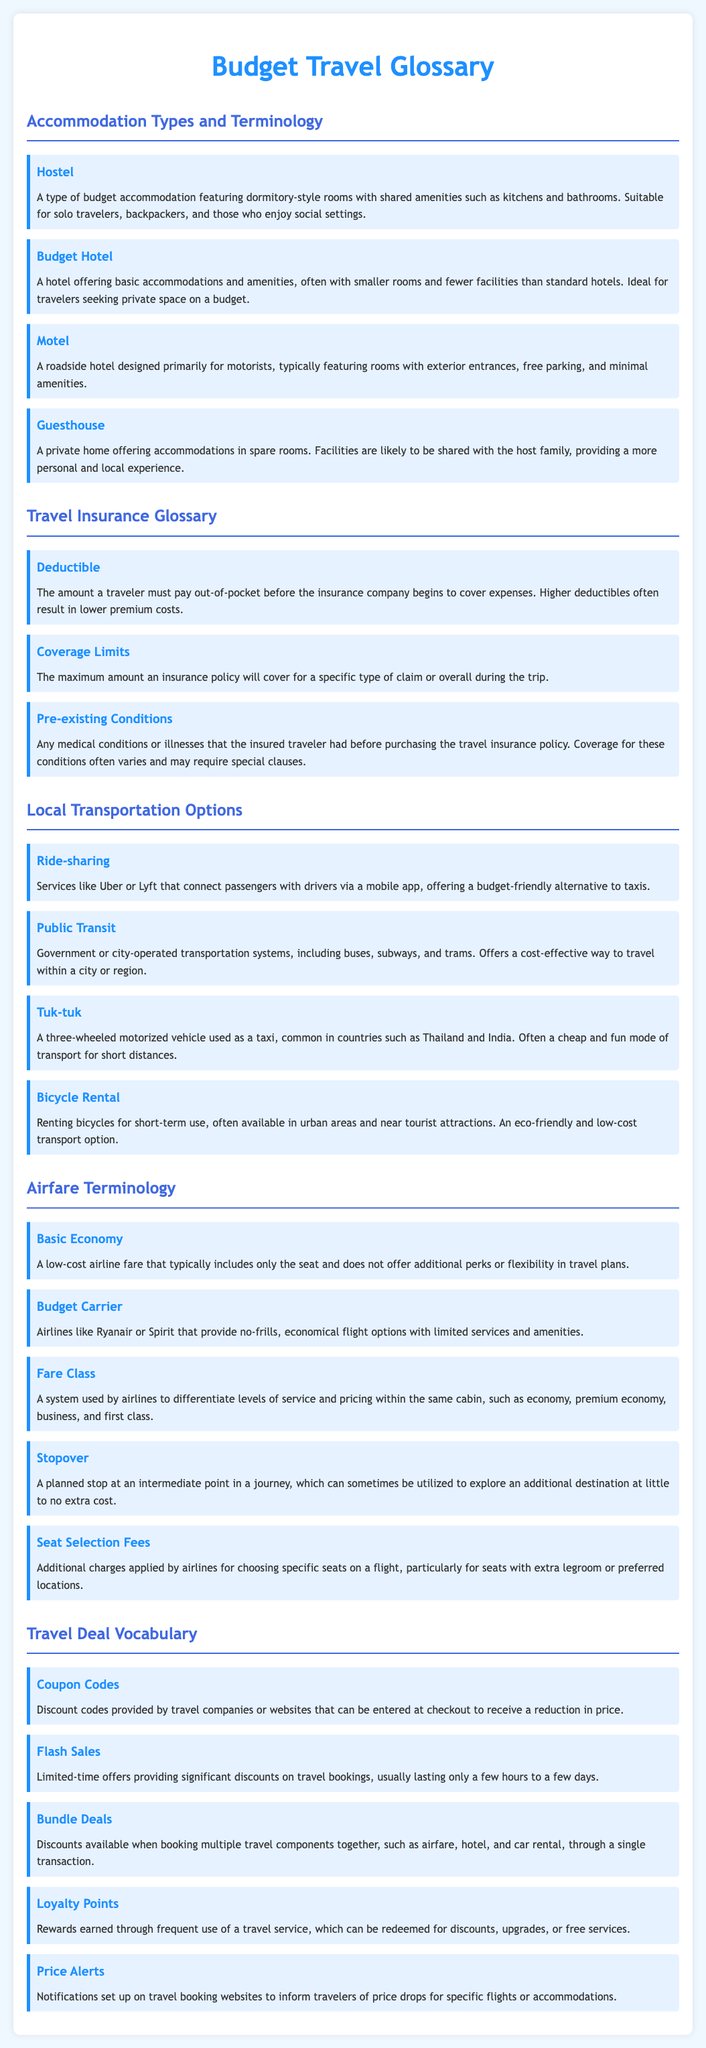What type of accommodation is often shared with other travelers? The document describes hostels as budget accommodations featuring dormitory-style rooms with shared amenities.
Answer: Hostel What is a common feature of motels? The glossary states that motels typically feature rooms with exterior entrances and free parking.
Answer: Free parking What does "deductible" refer to in travel insurance? The term deductible is defined as the amount a traveler must pay out-of-pocket before the insurance coverage begins.
Answer: Amount out-of-pocket What is a cost-effective method to travel within a city? The glossary mentions public transit as a government-operated transportation system offering a cost-effective way to travel.
Answer: Public transit What is a characteristic of budget carriers? Budget carriers are described as airlines providing no-frills, economical flight options.
Answer: No-frills What type of discount can you get from flash sales? Flash sales are defined as limited-time offers providing significant discounts on travel bookings.
Answer: Significant discounts What alert can travelers set up to track price drops? The document mentions price alerts as notifications to inform travelers of price drops for specific flights or accommodations.
Answer: Price alerts Which transportation option is often used as a taxi in certain countries? Tuk-tuks are described as three-wheeled motorized vehicles used as a taxi in countries like Thailand and India.
Answer: Tuk-tuk What can loyalty points be redeemed for? Loyalty points are rewards earned that can be redeemed for discounts, upgrades, or free services.
Answer: Discounts 